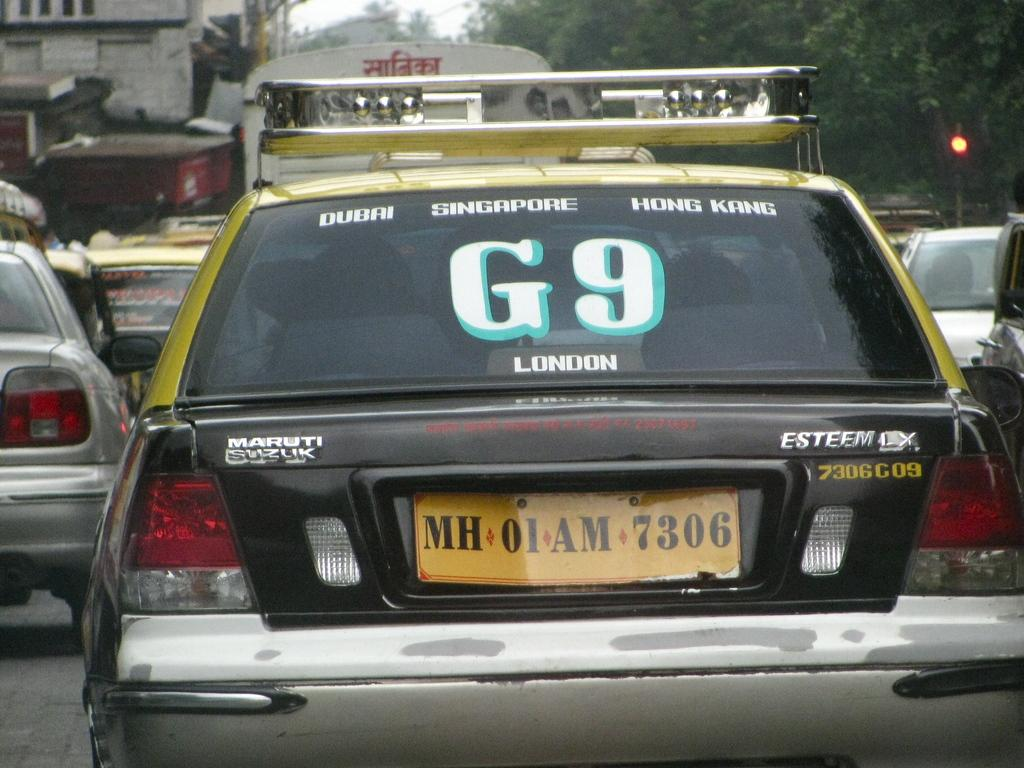<image>
Provide a brief description of the given image. Police car which has the letter and number G9 on it. 